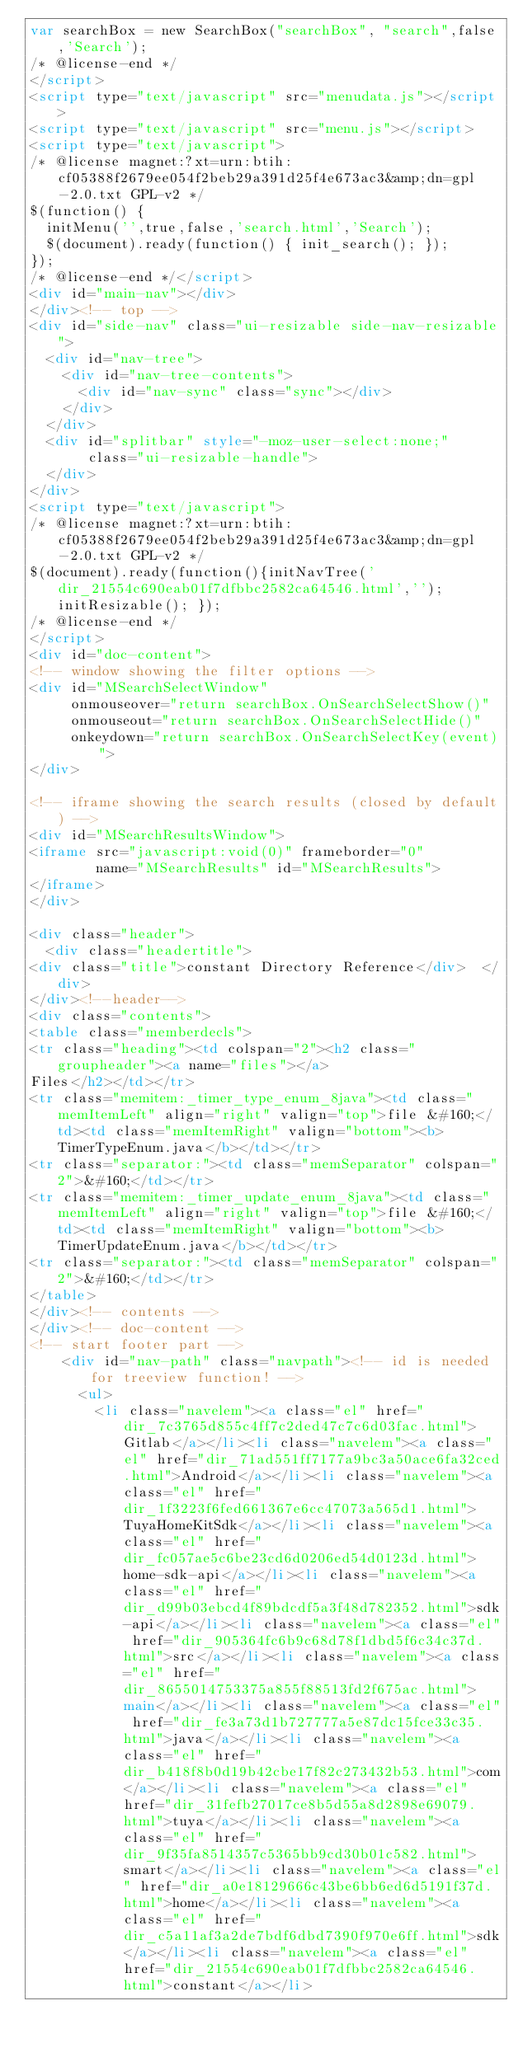Convert code to text. <code><loc_0><loc_0><loc_500><loc_500><_HTML_>var searchBox = new SearchBox("searchBox", "search",false,'Search');
/* @license-end */
</script>
<script type="text/javascript" src="menudata.js"></script>
<script type="text/javascript" src="menu.js"></script>
<script type="text/javascript">
/* @license magnet:?xt=urn:btih:cf05388f2679ee054f2beb29a391d25f4e673ac3&amp;dn=gpl-2.0.txt GPL-v2 */
$(function() {
  initMenu('',true,false,'search.html','Search');
  $(document).ready(function() { init_search(); });
});
/* @license-end */</script>
<div id="main-nav"></div>
</div><!-- top -->
<div id="side-nav" class="ui-resizable side-nav-resizable">
  <div id="nav-tree">
    <div id="nav-tree-contents">
      <div id="nav-sync" class="sync"></div>
    </div>
  </div>
  <div id="splitbar" style="-moz-user-select:none;" 
       class="ui-resizable-handle">
  </div>
</div>
<script type="text/javascript">
/* @license magnet:?xt=urn:btih:cf05388f2679ee054f2beb29a391d25f4e673ac3&amp;dn=gpl-2.0.txt GPL-v2 */
$(document).ready(function(){initNavTree('dir_21554c690eab01f7dfbbc2582ca64546.html',''); initResizable(); });
/* @license-end */
</script>
<div id="doc-content">
<!-- window showing the filter options -->
<div id="MSearchSelectWindow"
     onmouseover="return searchBox.OnSearchSelectShow()"
     onmouseout="return searchBox.OnSearchSelectHide()"
     onkeydown="return searchBox.OnSearchSelectKey(event)">
</div>

<!-- iframe showing the search results (closed by default) -->
<div id="MSearchResultsWindow">
<iframe src="javascript:void(0)" frameborder="0" 
        name="MSearchResults" id="MSearchResults">
</iframe>
</div>

<div class="header">
  <div class="headertitle">
<div class="title">constant Directory Reference</div>  </div>
</div><!--header-->
<div class="contents">
<table class="memberdecls">
<tr class="heading"><td colspan="2"><h2 class="groupheader"><a name="files"></a>
Files</h2></td></tr>
<tr class="memitem:_timer_type_enum_8java"><td class="memItemLeft" align="right" valign="top">file &#160;</td><td class="memItemRight" valign="bottom"><b>TimerTypeEnum.java</b></td></tr>
<tr class="separator:"><td class="memSeparator" colspan="2">&#160;</td></tr>
<tr class="memitem:_timer_update_enum_8java"><td class="memItemLeft" align="right" valign="top">file &#160;</td><td class="memItemRight" valign="bottom"><b>TimerUpdateEnum.java</b></td></tr>
<tr class="separator:"><td class="memSeparator" colspan="2">&#160;</td></tr>
</table>
</div><!-- contents -->
</div><!-- doc-content -->
<!-- start footer part -->
		<div id="nav-path" class="navpath"><!-- id is needed for treeview function! -->
			<ul>
				<li class="navelem"><a class="el" href="dir_7c3765d855c4ff7c2ded47c7c6d03fac.html">Gitlab</a></li><li class="navelem"><a class="el" href="dir_71ad551ff7177a9bc3a50ace6fa32ced.html">Android</a></li><li class="navelem"><a class="el" href="dir_1f3223f6fed661367e6cc47073a565d1.html">TuyaHomeKitSdk</a></li><li class="navelem"><a class="el" href="dir_fc057ae5c6be23cd6d0206ed54d0123d.html">home-sdk-api</a></li><li class="navelem"><a class="el" href="dir_d99b03ebcd4f89bdcdf5a3f48d782352.html">sdk-api</a></li><li class="navelem"><a class="el" href="dir_905364fc6b9c68d78f1dbd5f6c34c37d.html">src</a></li><li class="navelem"><a class="el" href="dir_8655014753375a855f88513fd2f675ac.html">main</a></li><li class="navelem"><a class="el" href="dir_fe3a73d1b727777a5e87dc15fce33c35.html">java</a></li><li class="navelem"><a class="el" href="dir_b418f8b0d19b42cbe17f82c273432b53.html">com</a></li><li class="navelem"><a class="el" href="dir_31fefb27017ce8b5d55a8d2898e69079.html">tuya</a></li><li class="navelem"><a class="el" href="dir_9f35fa8514357c5365bb9cd30b01c582.html">smart</a></li><li class="navelem"><a class="el" href="dir_a0e18129666c43be6bb6ed6d5191f37d.html">home</a></li><li class="navelem"><a class="el" href="dir_c5a11af3a2de7bdf6dbd7390f970e6ff.html">sdk</a></li><li class="navelem"><a class="el" href="dir_21554c690eab01f7dfbbc2582ca64546.html">constant</a></li></code> 